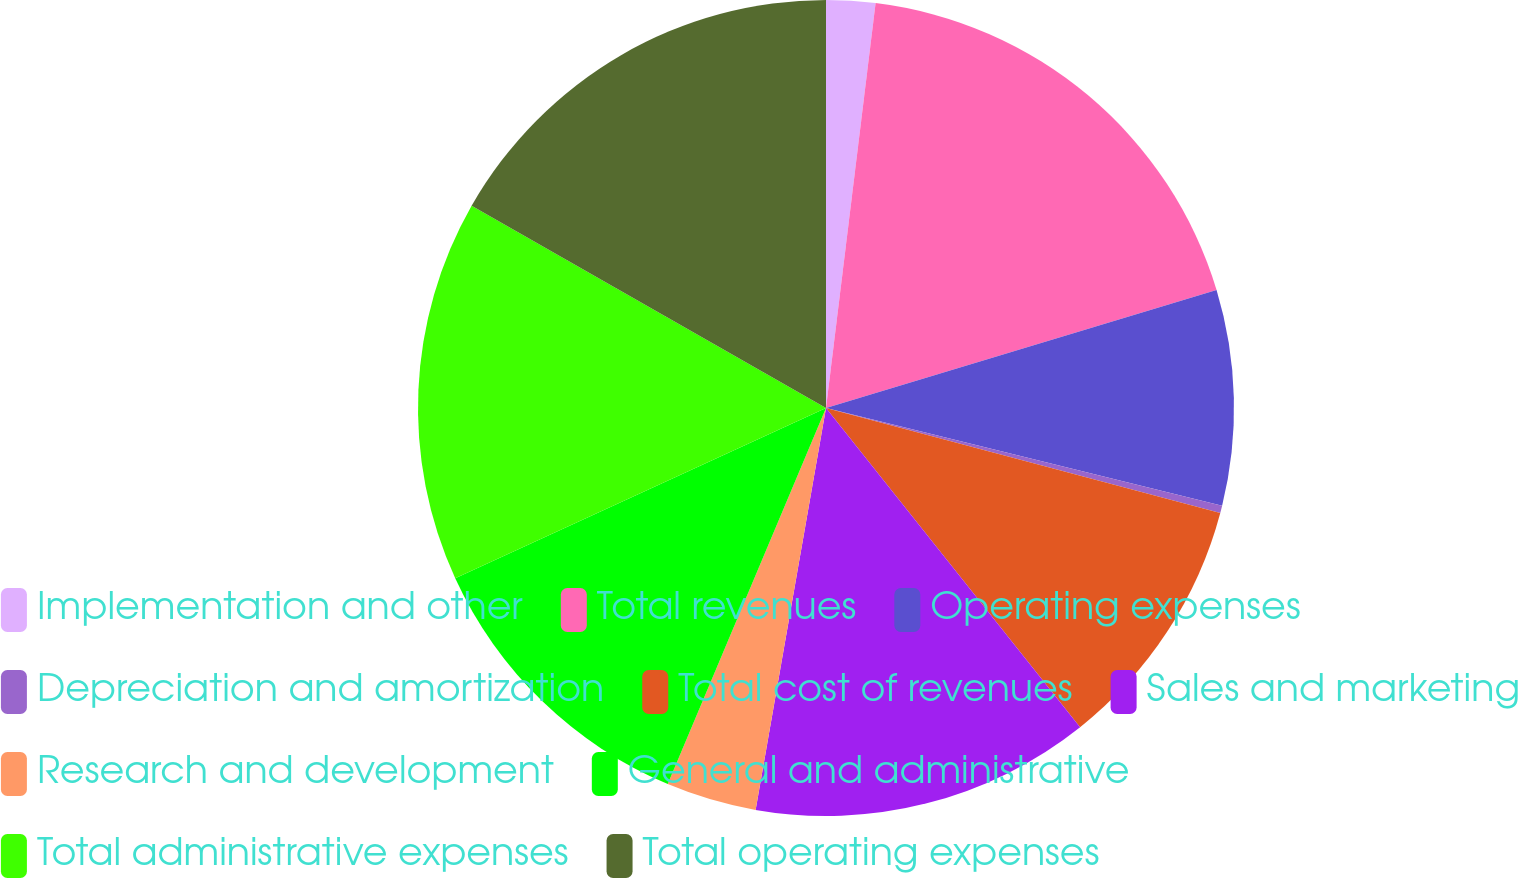Convert chart. <chart><loc_0><loc_0><loc_500><loc_500><pie_chart><fcel>Implementation and other<fcel>Total revenues<fcel>Operating expenses<fcel>Depreciation and amortization<fcel>Total cost of revenues<fcel>Sales and marketing<fcel>Research and development<fcel>General and administrative<fcel>Total administrative expenses<fcel>Total operating expenses<nl><fcel>1.94%<fcel>18.39%<fcel>8.52%<fcel>0.29%<fcel>10.16%<fcel>13.46%<fcel>3.58%<fcel>11.81%<fcel>15.1%<fcel>16.75%<nl></chart> 